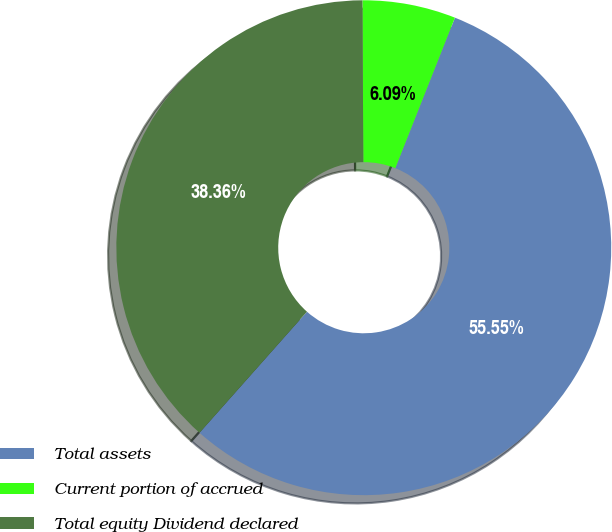<chart> <loc_0><loc_0><loc_500><loc_500><pie_chart><fcel>Total assets<fcel>Current portion of accrued<fcel>Total equity Dividend declared<nl><fcel>55.55%<fcel>6.09%<fcel>38.36%<nl></chart> 